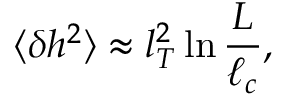Convert formula to latex. <formula><loc_0><loc_0><loc_500><loc_500>\langle \delta h ^ { 2 } \rangle \approx l _ { T } ^ { 2 } \ln \frac { L } { \ell _ { c } } ,</formula> 